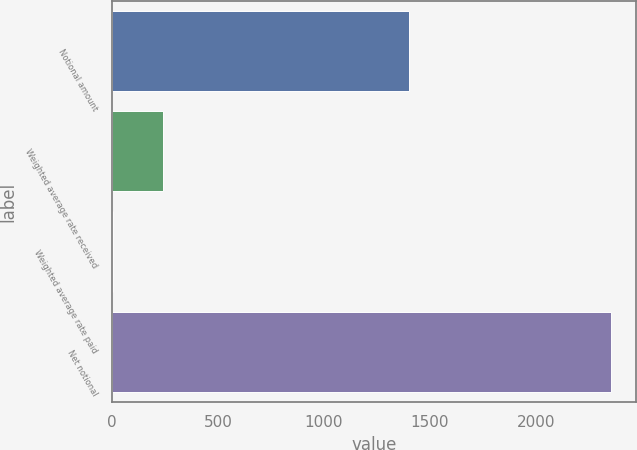Convert chart. <chart><loc_0><loc_0><loc_500><loc_500><bar_chart><fcel>Notional amount<fcel>Weighted average rate received<fcel>Weighted average rate paid<fcel>Net notional<nl><fcel>1400<fcel>239.92<fcel>4.91<fcel>2355<nl></chart> 